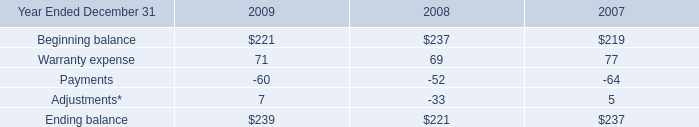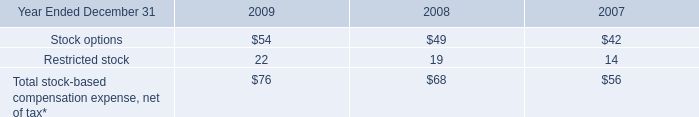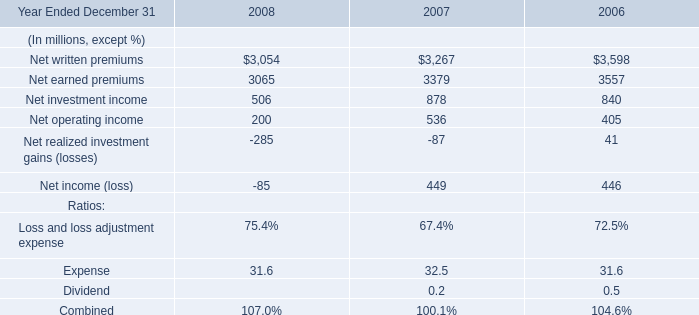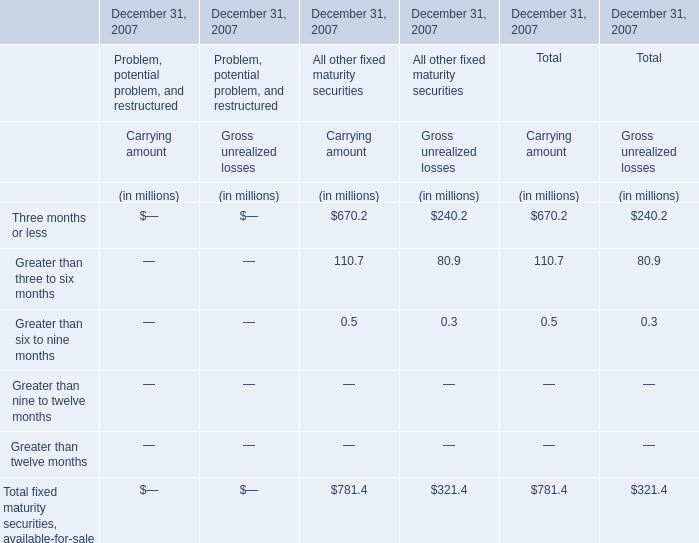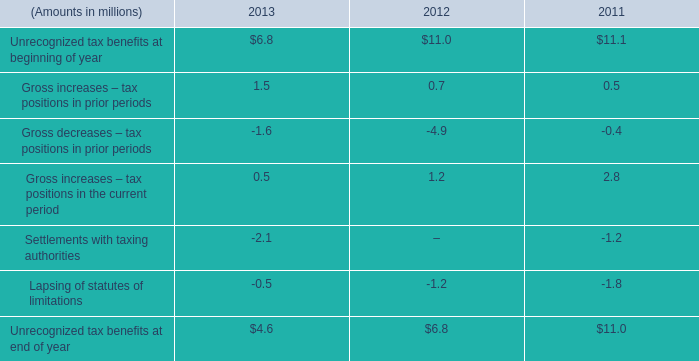in 2013 what was the percent of the unrecognized income tax benefit that could impact effective income tax rate if recognized 
Computations: (4.1 / 4.6)
Answer: 0.8913. 